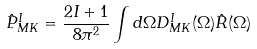<formula> <loc_0><loc_0><loc_500><loc_500>\hat { P } ^ { I } _ { M K } = \frac { 2 I + 1 } { 8 \pi ^ { 2 } } \int d \Omega D ^ { I } _ { M K } ( \Omega ) \hat { R } ( \Omega )</formula> 